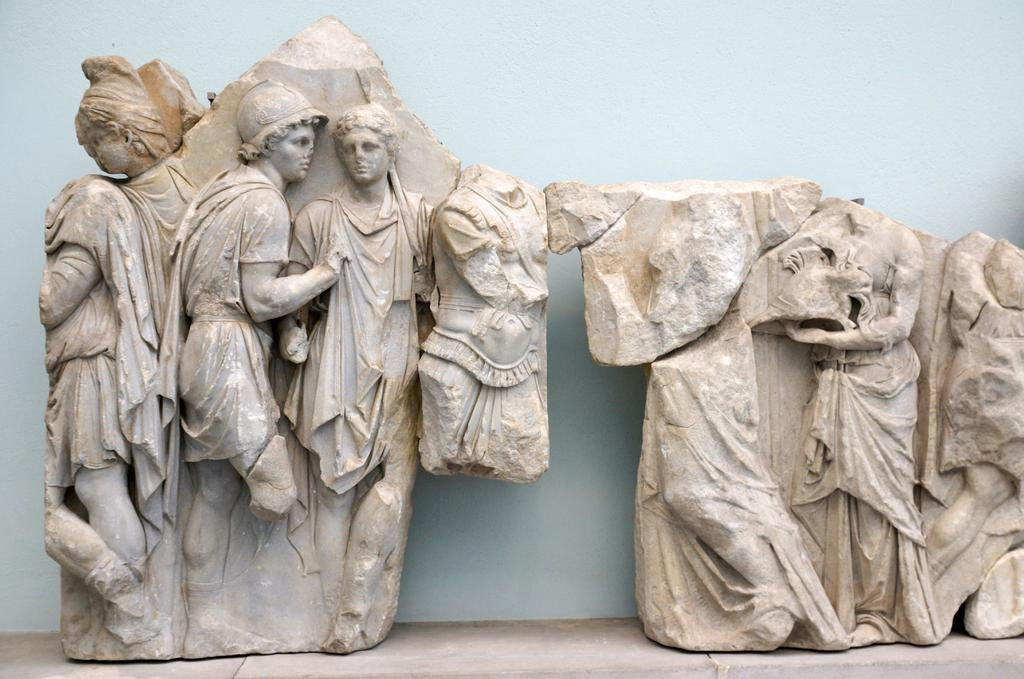What type of art is depicted in the image? There are sculptures of people in the image. What can be seen in the background of the image? There is a wall in the background of the image. What type of jam is being spread on the calendar in the image? There is no jam or calendar present in the image; it only features sculptures of people and a wall in the background. 